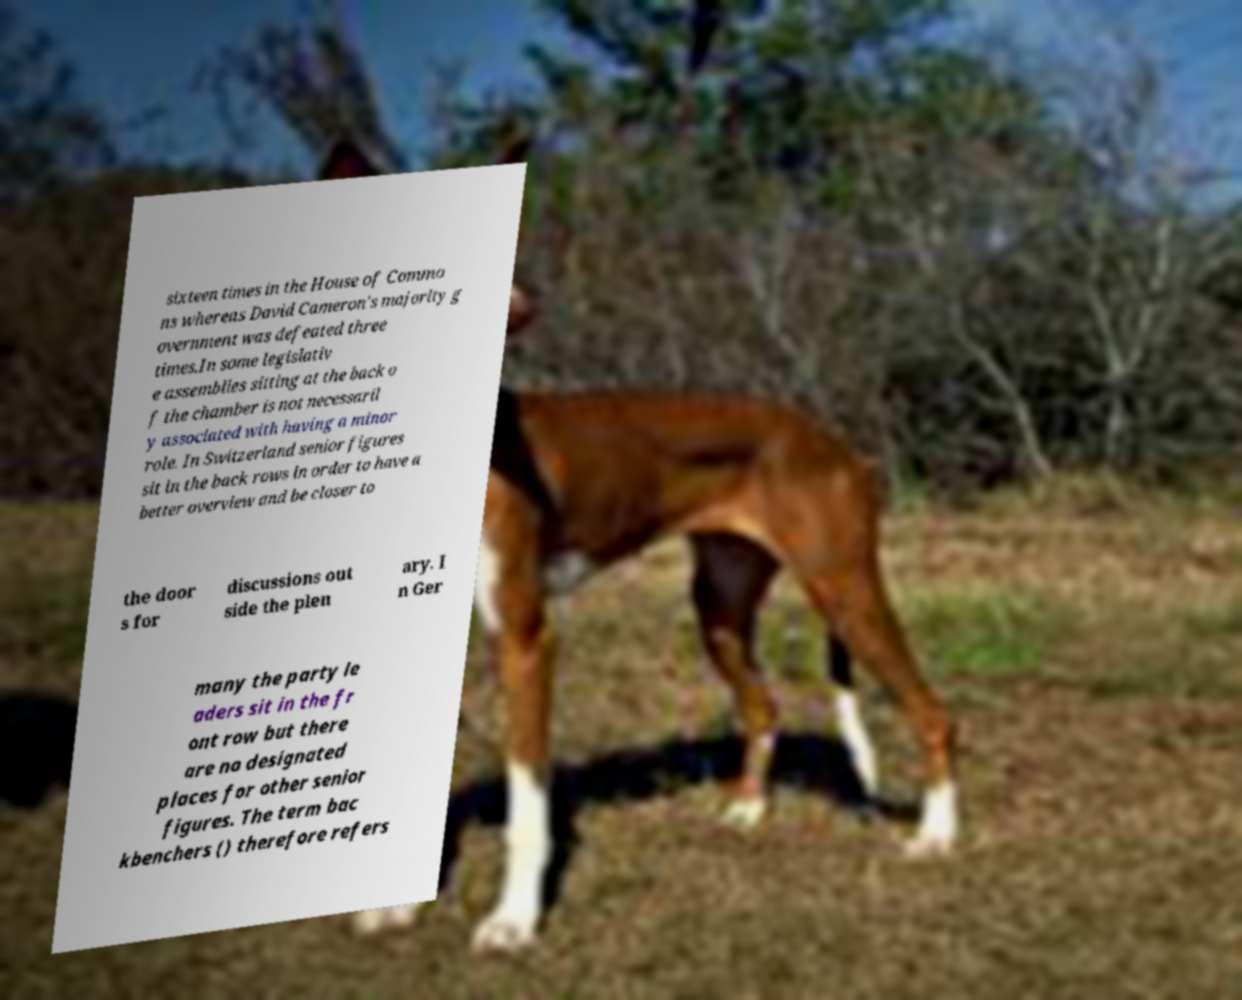Please read and relay the text visible in this image. What does it say? sixteen times in the House of Commo ns whereas David Cameron's majority g overnment was defeated three times.In some legislativ e assemblies sitting at the back o f the chamber is not necessaril y associated with having a minor role. In Switzerland senior figures sit in the back rows in order to have a better overview and be closer to the door s for discussions out side the plen ary. I n Ger many the party le aders sit in the fr ont row but there are no designated places for other senior figures. The term bac kbenchers () therefore refers 